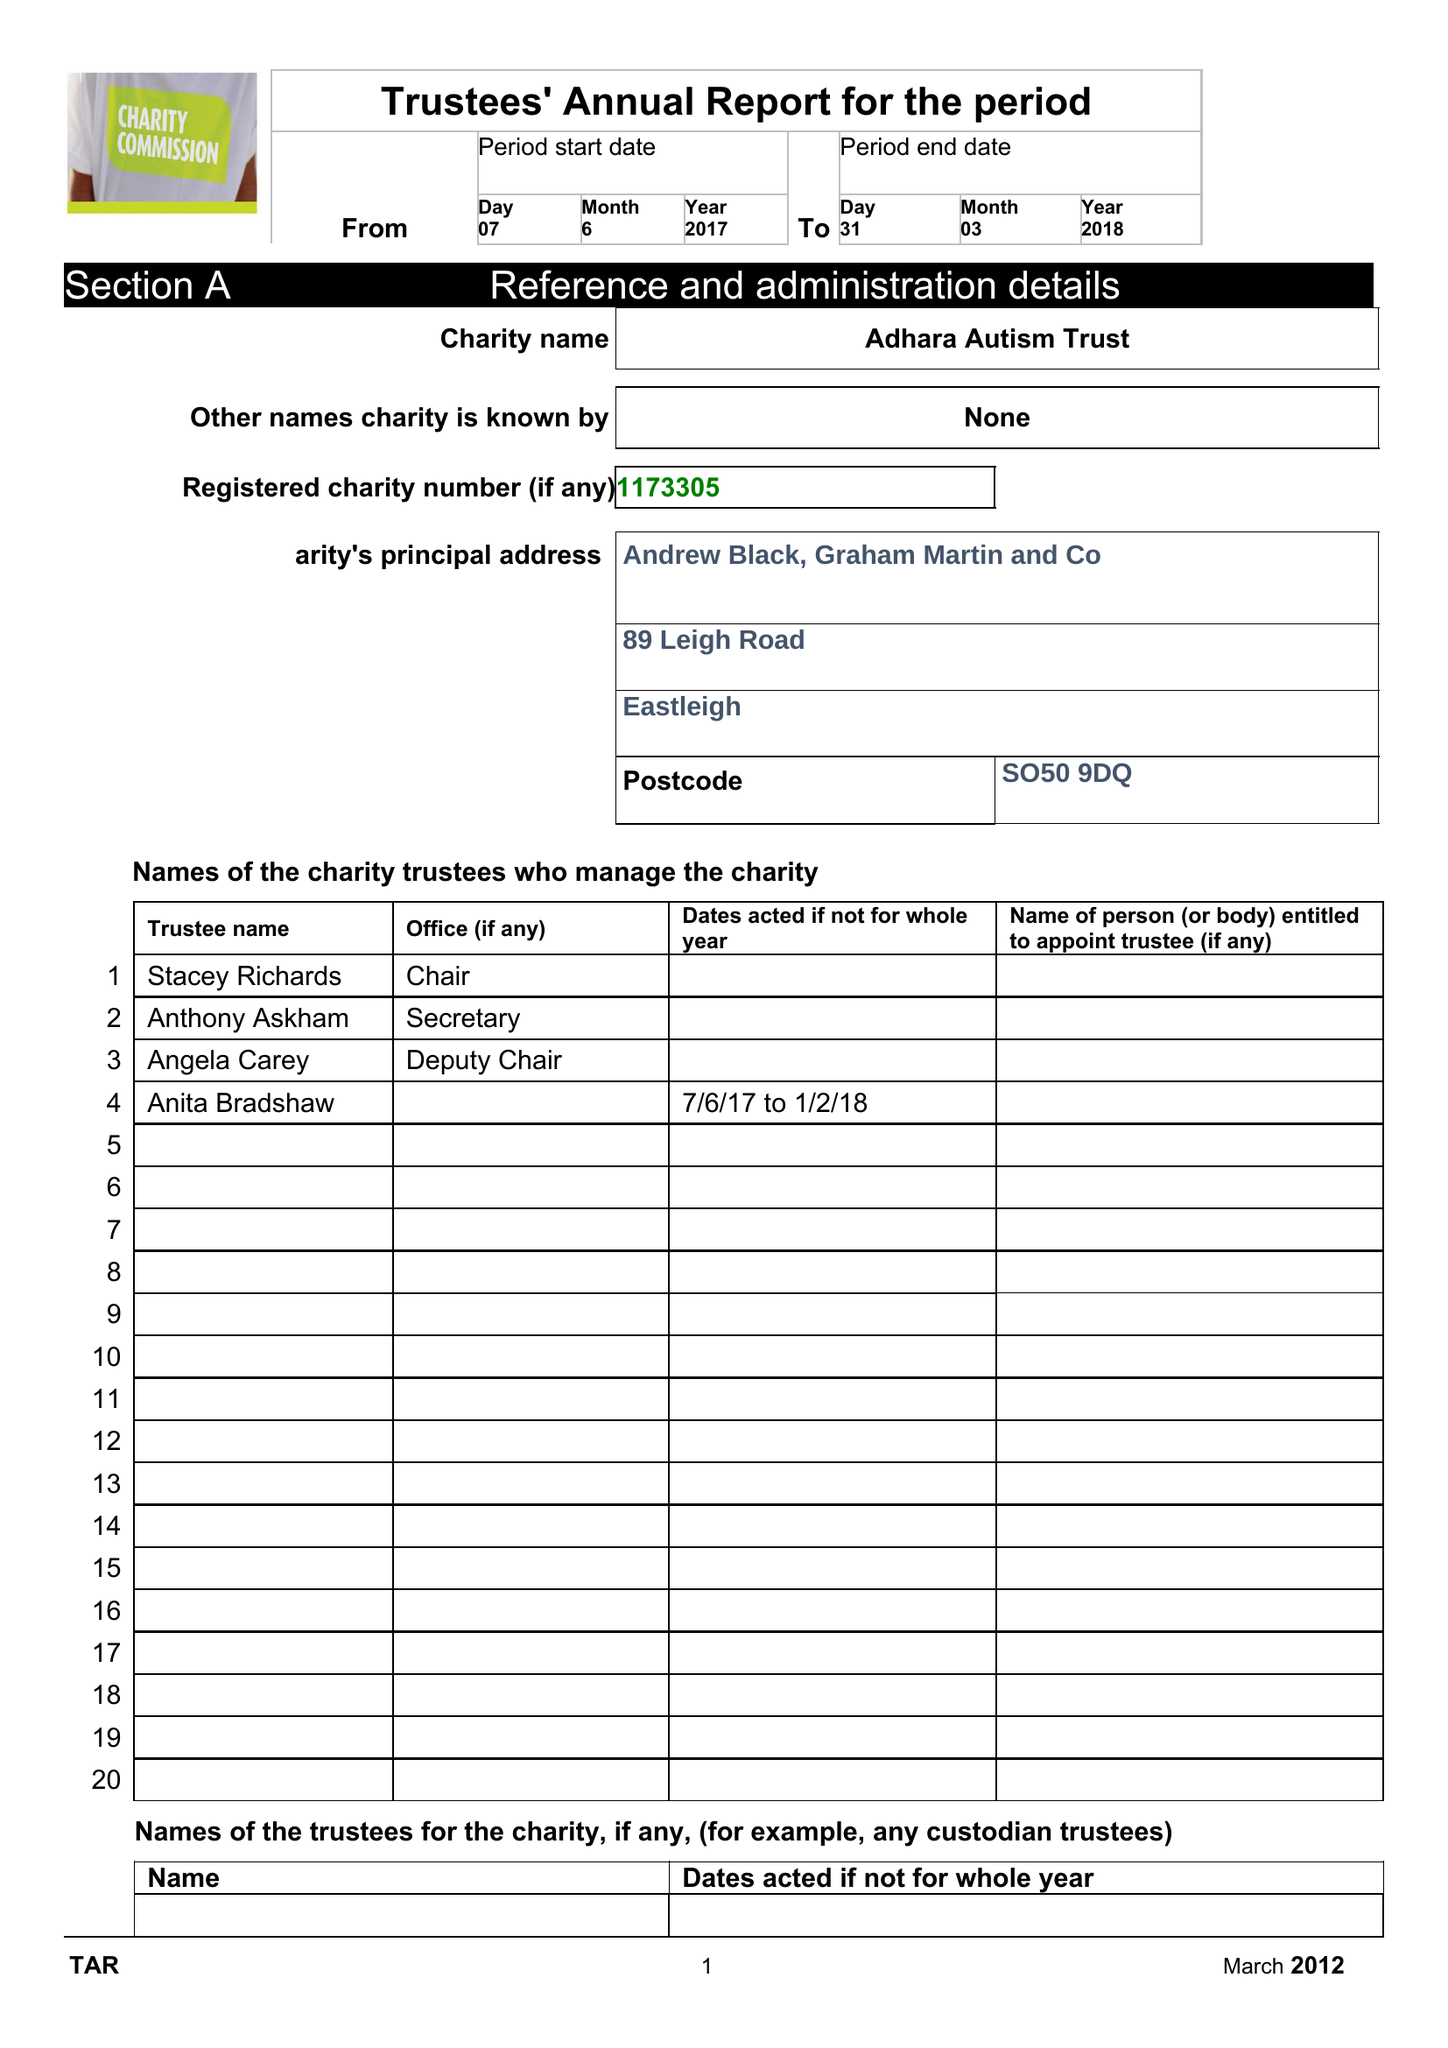What is the value for the charity_number?
Answer the question using a single word or phrase. 1173305 